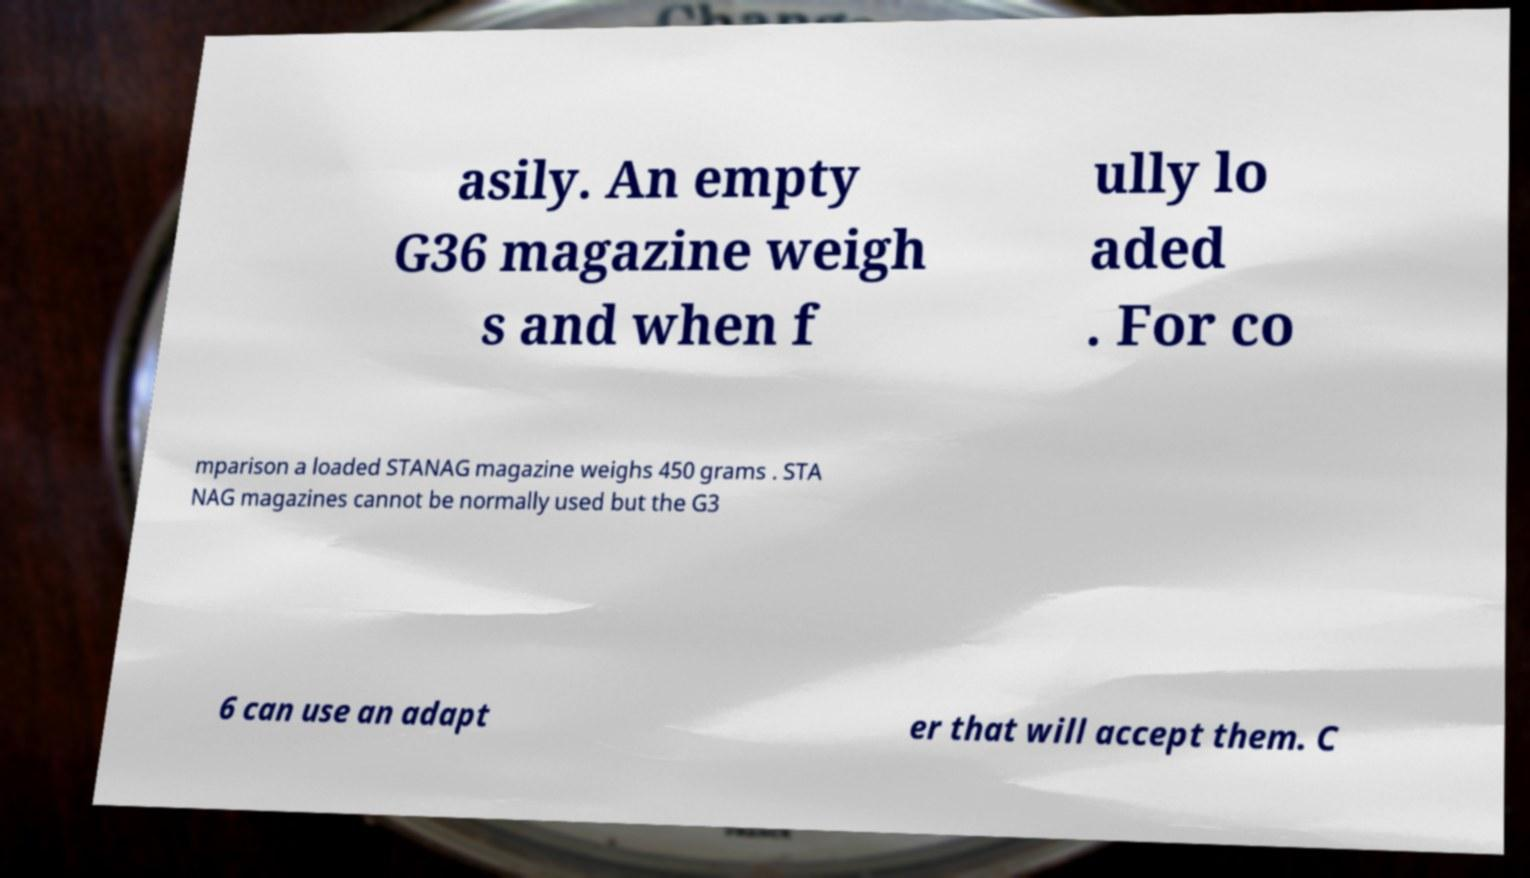Could you extract and type out the text from this image? asily. An empty G36 magazine weigh s and when f ully lo aded . For co mparison a loaded STANAG magazine weighs 450 grams . STA NAG magazines cannot be normally used but the G3 6 can use an adapt er that will accept them. C 